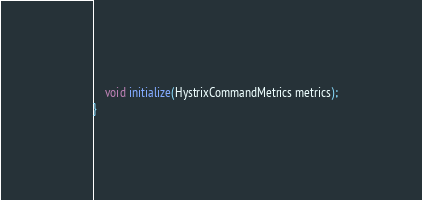<code> <loc_0><loc_0><loc_500><loc_500><_Java_>
    void initialize(HystrixCommandMetrics metrics);
}
</code> 